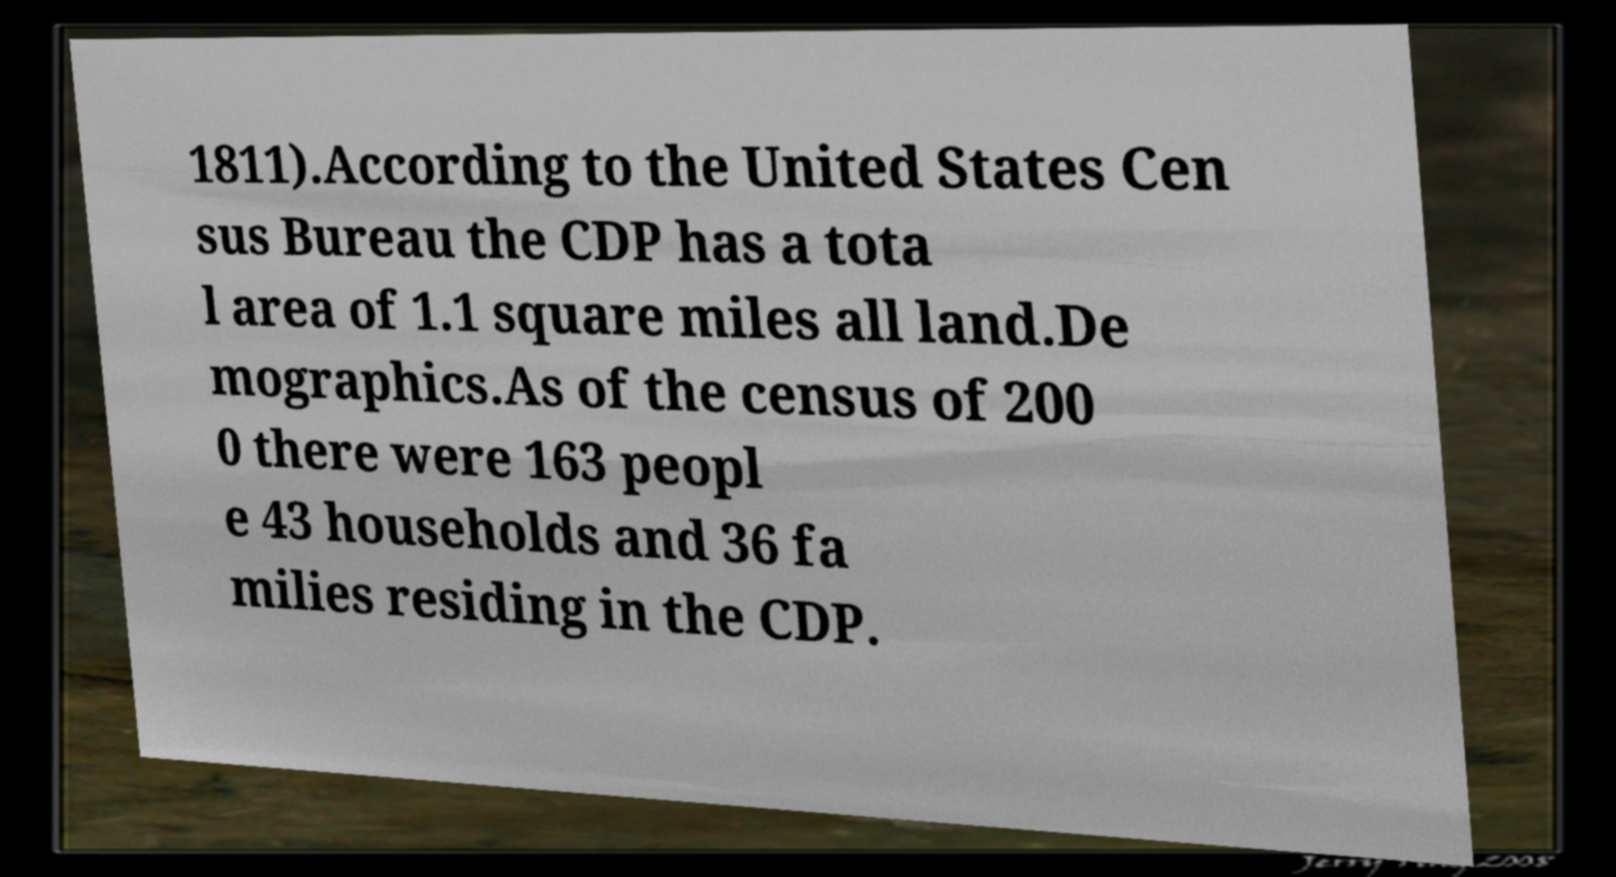Can you read and provide the text displayed in the image?This photo seems to have some interesting text. Can you extract and type it out for me? 1811).According to the United States Cen sus Bureau the CDP has a tota l area of 1.1 square miles all land.De mographics.As of the census of 200 0 there were 163 peopl e 43 households and 36 fa milies residing in the CDP. 